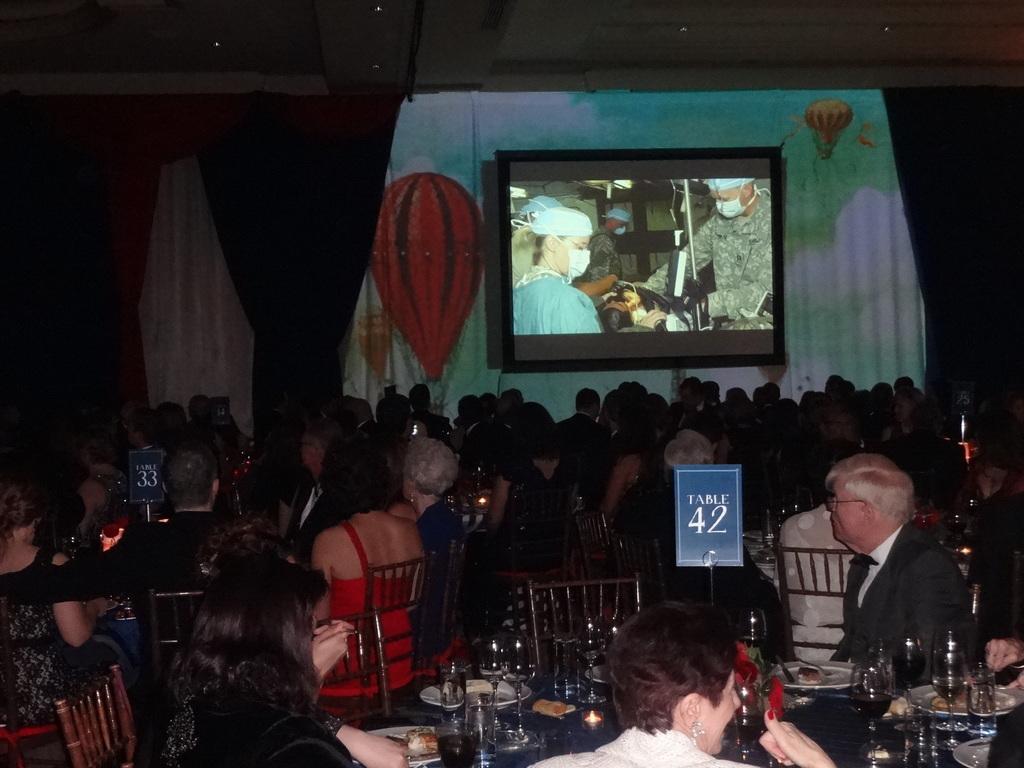How would you summarize this image in a sentence or two? In this image we can see a group of people sitting on chairs, boards with some text. In the foreground we can see group of glasses, plates containing food, candles and some flowers placed on the table. In the center of the image we can see a screen, curtains, group of lights and some paintings on the wall. 